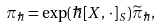<formula> <loc_0><loc_0><loc_500><loc_500>\pi _ { \hbar } = \exp ( \hbar { [ } X , \, \cdot \, ] _ { S } ) \widetilde { \pi } _ { \hbar } ,</formula> 